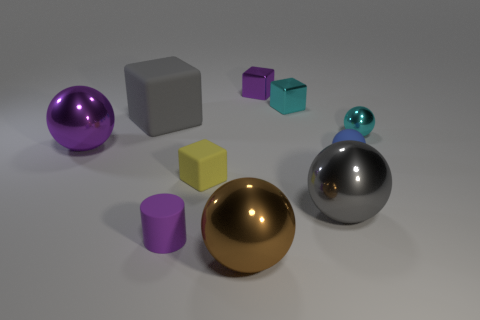What number of other gray blocks have the same size as the gray matte block?
Keep it short and to the point. 0. What material is the tiny thing that is to the right of the gray sphere and behind the large purple metallic ball?
Your answer should be very brief. Metal. How many cyan metal things are behind the brown ball?
Give a very brief answer. 2. Does the yellow thing have the same shape as the cyan object that is right of the rubber ball?
Your response must be concise. No. Is there a tiny cyan shiny thing of the same shape as the gray shiny thing?
Offer a terse response. Yes. There is a gray thing that is behind the big metallic thing that is on the left side of the small cylinder; what is its shape?
Your answer should be very brief. Cube. There is a metallic object to the left of the small purple cylinder; what shape is it?
Your response must be concise. Sphere. There is a cube on the left side of the tiny yellow block; is it the same color as the big thing that is to the right of the big brown sphere?
Provide a succinct answer. Yes. How many small objects are in front of the large rubber object and on the right side of the purple matte cylinder?
Your response must be concise. 3. There is a gray ball that is made of the same material as the brown object; what size is it?
Offer a very short reply. Large. 